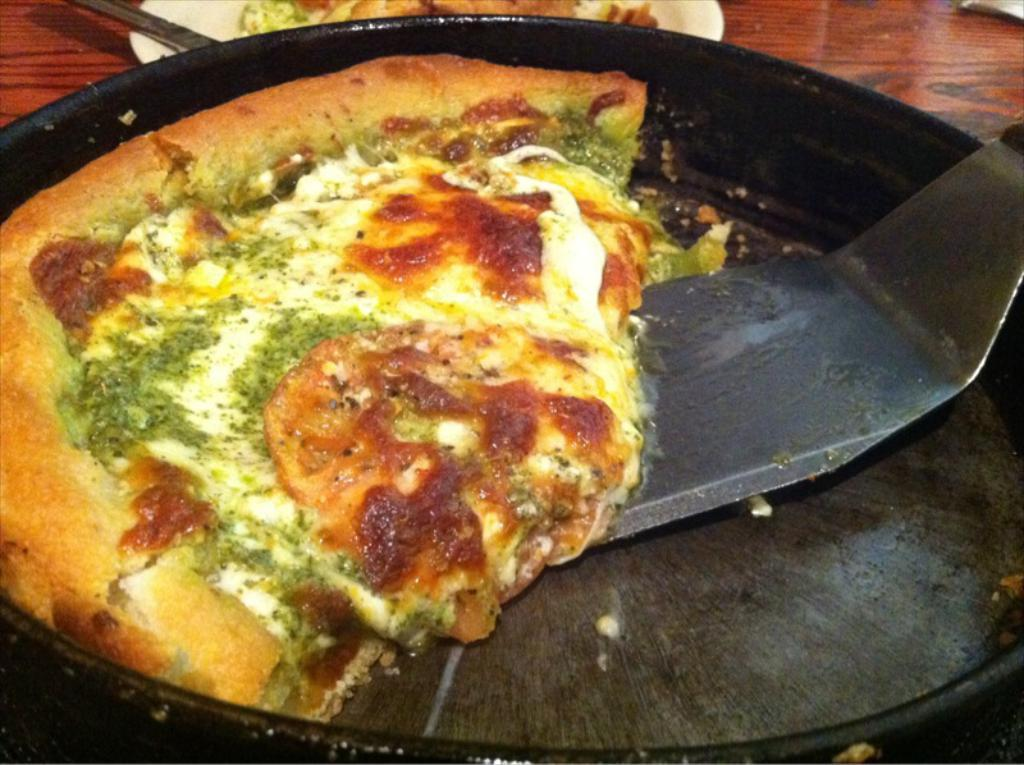What is on the serving plate in the image? The serving plate contains pie. What object is also present in the serving plate? There is a spatula in the serving plate. What might be used to serve the pie from the plate? The spatula could be used to serve the pie from the plate. What type of chess piece is on the pie in the image? There is no chess piece present on the pie in the image. What material is the wool used to make the pie crust in the image? There is no wool mentioned in the image, and the pie crust is not described as being made from wool. 